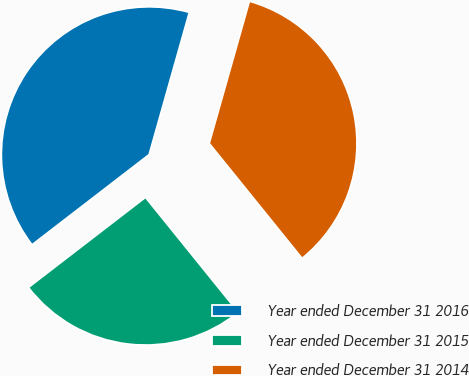Convert chart to OTSL. <chart><loc_0><loc_0><loc_500><loc_500><pie_chart><fcel>Year ended December 31 2016<fcel>Year ended December 31 2015<fcel>Year ended December 31 2014<nl><fcel>39.83%<fcel>25.37%<fcel>34.8%<nl></chart> 